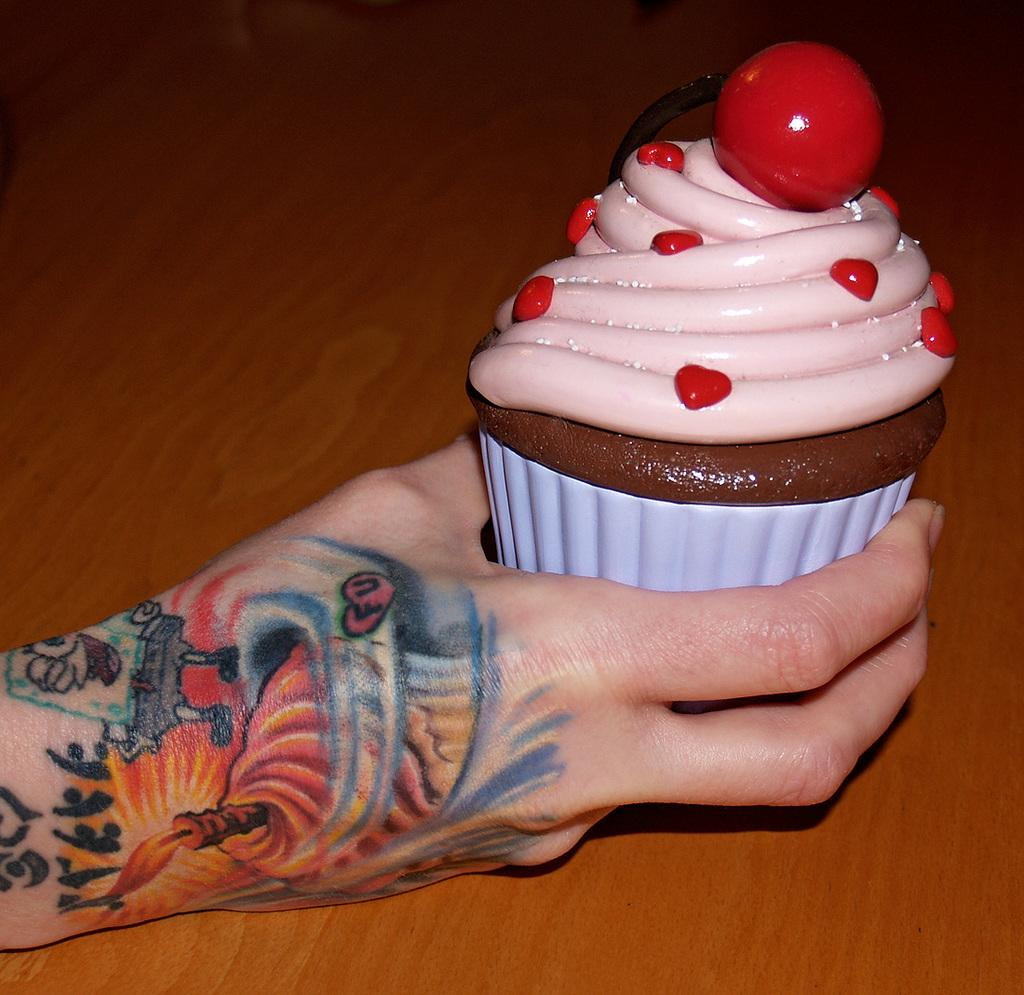What is the person's hand holding in the image? The person's hand is holding a cupcake in the image. What can be seen on the person's hand? There are tattoos on the hand. What color is the surface in the background? The surface in the background is brown-colored. What type of line is being processed in the image? There is no line or process depicted in the image; it features a person's hand holding a cupcake with tattoos on it. How many drops of water can be seen falling from the cupcake in the image? There are no drops of water visible on the cupcake in the image. 